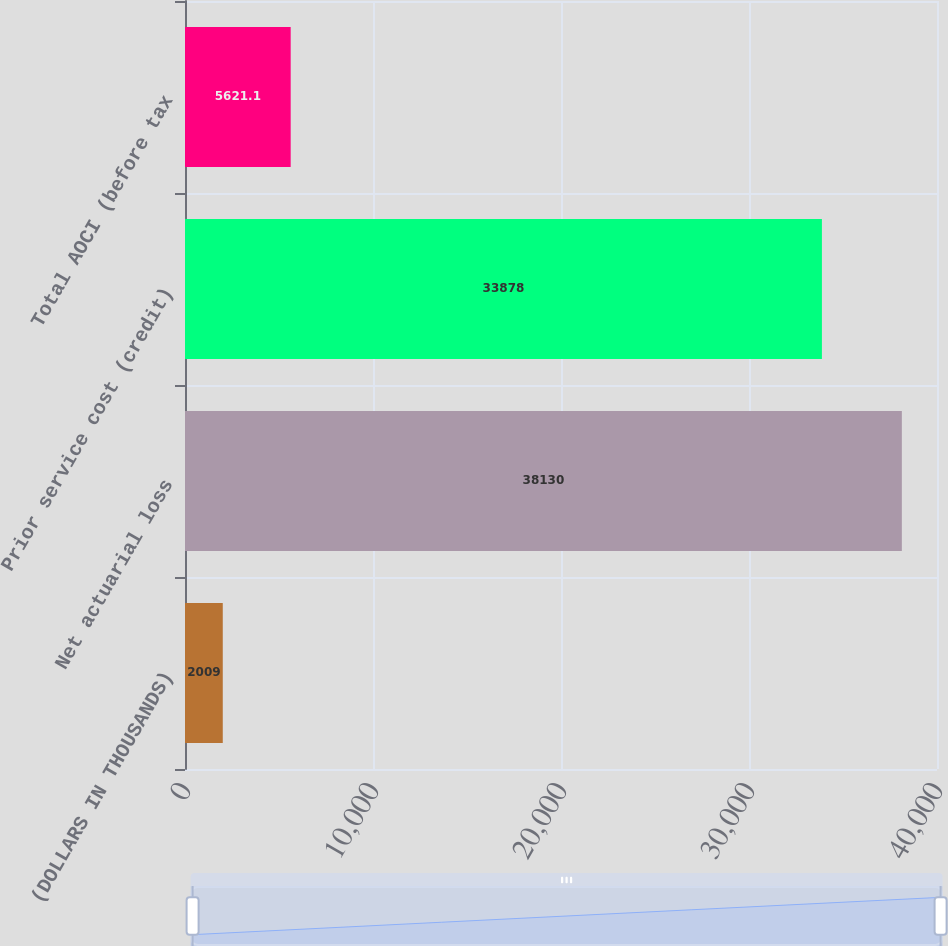Convert chart to OTSL. <chart><loc_0><loc_0><loc_500><loc_500><bar_chart><fcel>(DOLLARS IN THOUSANDS)<fcel>Net actuarial loss<fcel>Prior service cost (credit)<fcel>Total AOCI (before tax<nl><fcel>2009<fcel>38130<fcel>33878<fcel>5621.1<nl></chart> 